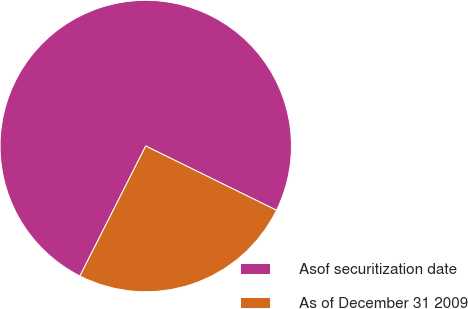Convert chart to OTSL. <chart><loc_0><loc_0><loc_500><loc_500><pie_chart><fcel>Asof securitization date<fcel>As of December 31 2009<nl><fcel>74.81%<fcel>25.19%<nl></chart> 